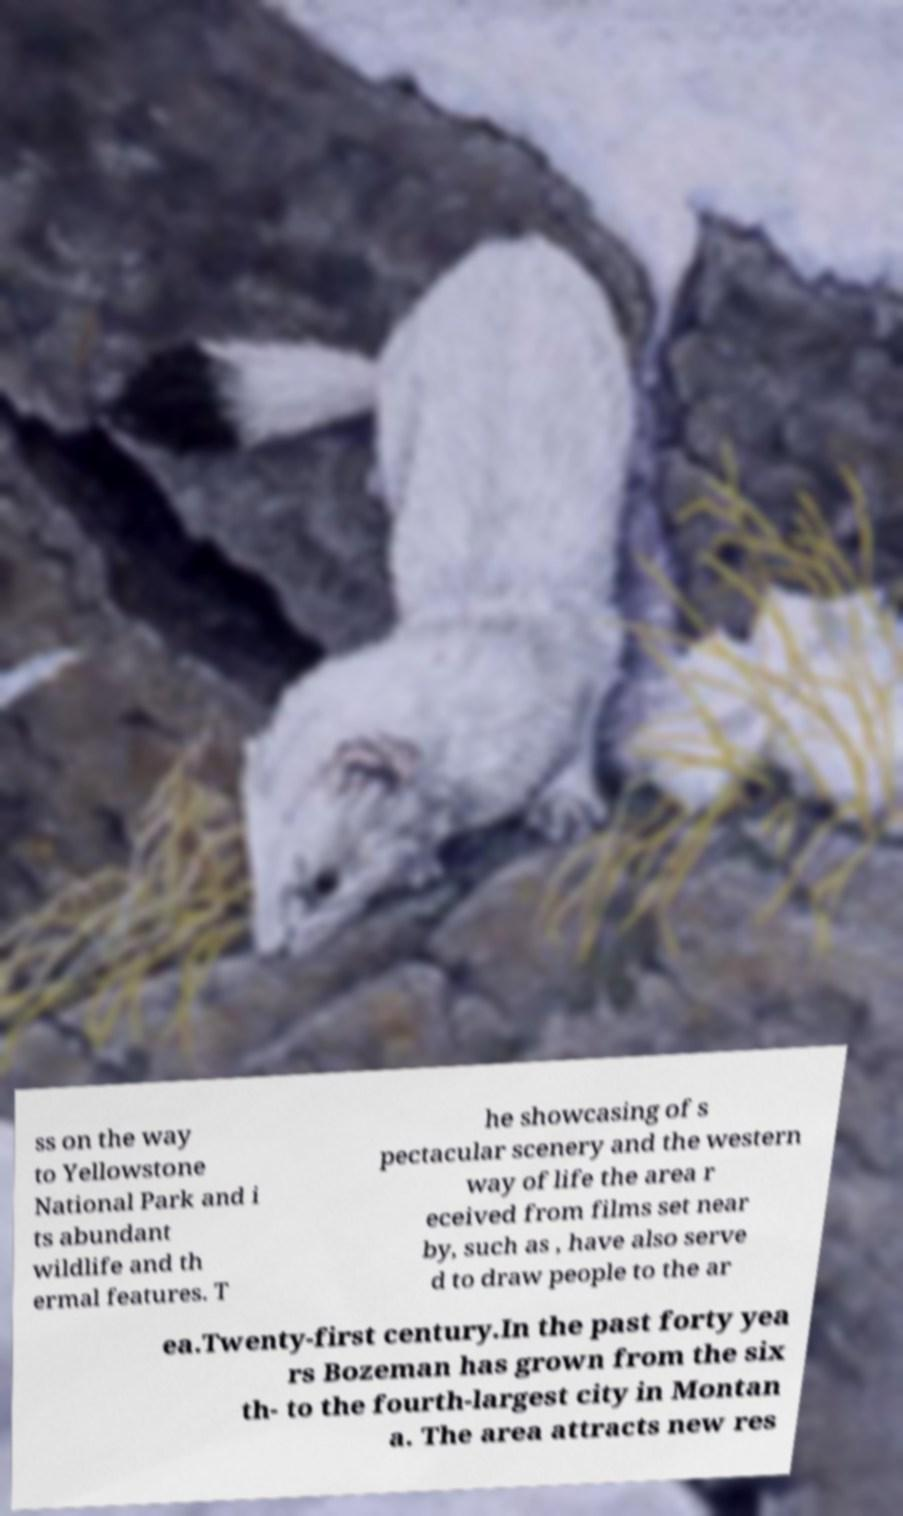There's text embedded in this image that I need extracted. Can you transcribe it verbatim? ss on the way to Yellowstone National Park and i ts abundant wildlife and th ermal features. T he showcasing of s pectacular scenery and the western way of life the area r eceived from films set near by, such as , have also serve d to draw people to the ar ea.Twenty-first century.In the past forty yea rs Bozeman has grown from the six th- to the fourth-largest city in Montan a. The area attracts new res 